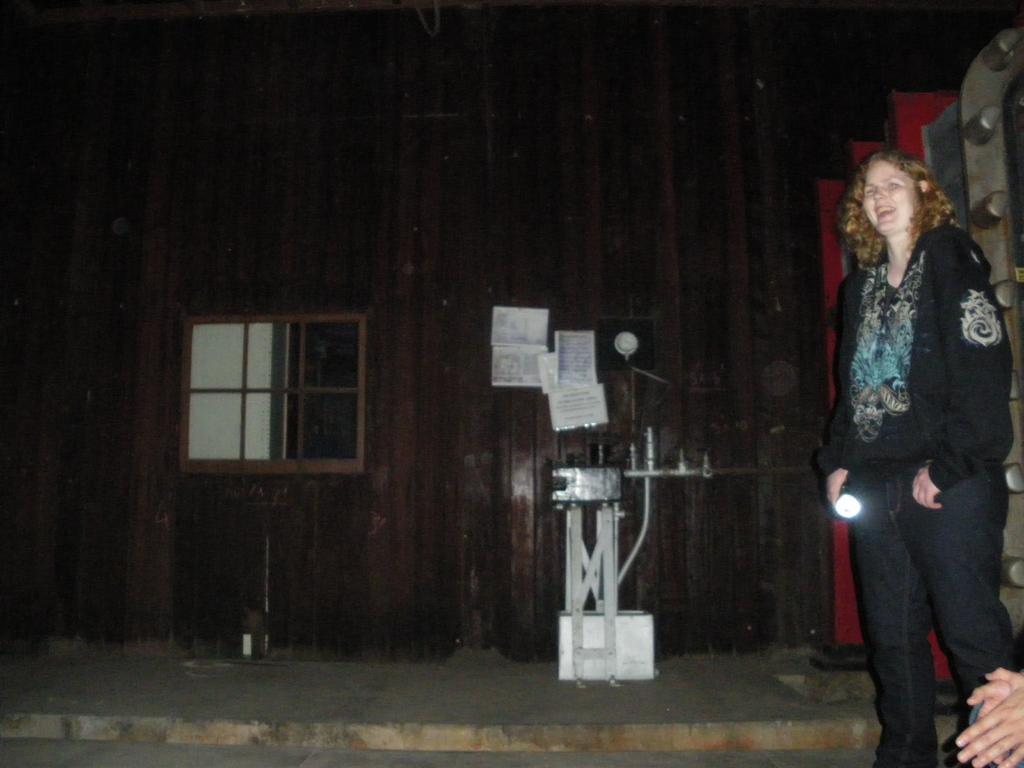In one or two sentences, can you explain what this image depicts? In this picture we can see few people, on the right side of the image we can see a woman, she is smiling, beside to her we can see few metal rods and papers on the wall. 